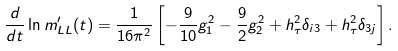<formula> <loc_0><loc_0><loc_500><loc_500>\frac { d } { d t } \ln m ^ { \prime } _ { L L } ( t ) = \frac { 1 } { 1 6 \pi ^ { 2 } } \left [ - \frac { 9 } { 1 0 } g ^ { 2 } _ { 1 } - \frac { 9 } { 2 } g ^ { 2 } _ { 2 } + h ^ { 2 } _ { \tau } \delta _ { i 3 } + h ^ { 2 } _ { \tau } \delta _ { 3 j } \right ] .</formula> 